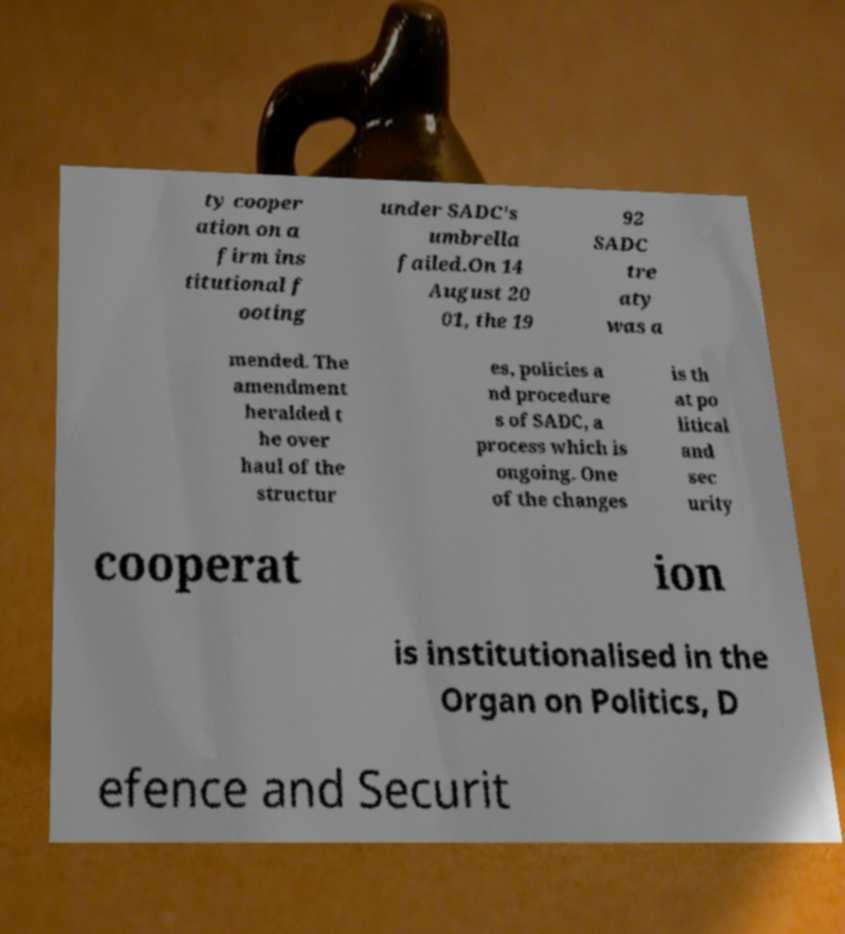What messages or text are displayed in this image? I need them in a readable, typed format. ty cooper ation on a firm ins titutional f ooting under SADC's umbrella failed.On 14 August 20 01, the 19 92 SADC tre aty was a mended. The amendment heralded t he over haul of the structur es, policies a nd procedure s of SADC, a process which is ongoing. One of the changes is th at po litical and sec urity cooperat ion is institutionalised in the Organ on Politics, D efence and Securit 